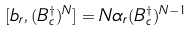Convert formula to latex. <formula><loc_0><loc_0><loc_500><loc_500>[ b _ { r } , ( B _ { c } ^ { \dagger } ) ^ { N } ] = N \alpha _ { r } ( B _ { c } ^ { \dagger } ) ^ { N - 1 }</formula> 